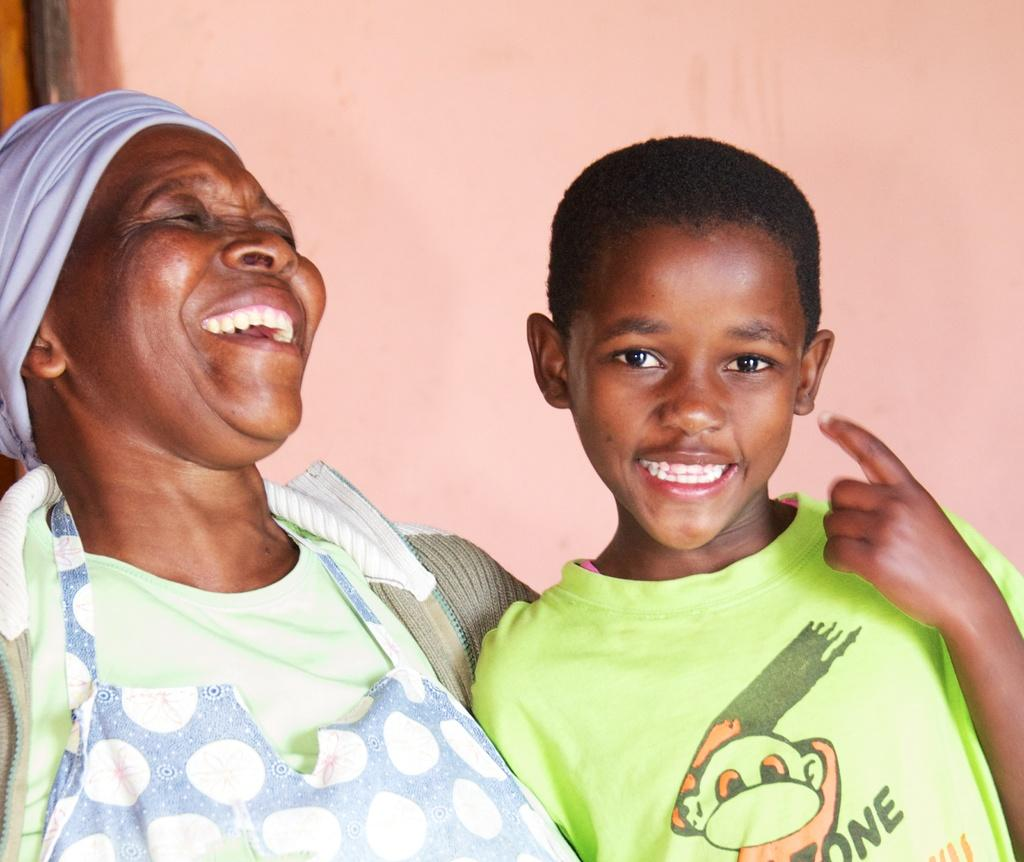How many individuals are present in the image? There are two people in the image. What is the facial expression of the people in the image? The people are smiling. What can be seen behind the people in the image? There is a wall behind the people. How much does a ticket to the event cost in the image? There is no event or ticket present in the image; it features two people smiling in front of a wall. 